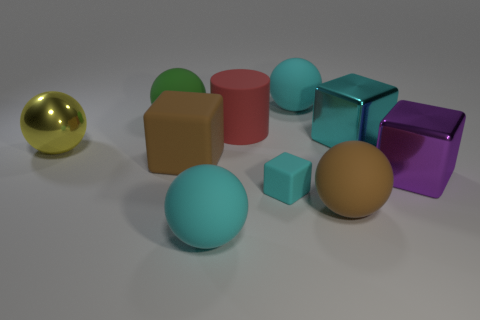Subtract 3 balls. How many balls are left? 2 Subtract all brown spheres. How many spheres are left? 4 Subtract all big green balls. How many balls are left? 4 Subtract all blue balls. Subtract all red cylinders. How many balls are left? 5 Subtract all cylinders. How many objects are left? 9 Add 4 small cyan objects. How many small cyan objects are left? 5 Add 6 big cyan matte cylinders. How many big cyan matte cylinders exist? 6 Subtract 0 purple cylinders. How many objects are left? 10 Subtract all large green metallic objects. Subtract all small cyan rubber cubes. How many objects are left? 9 